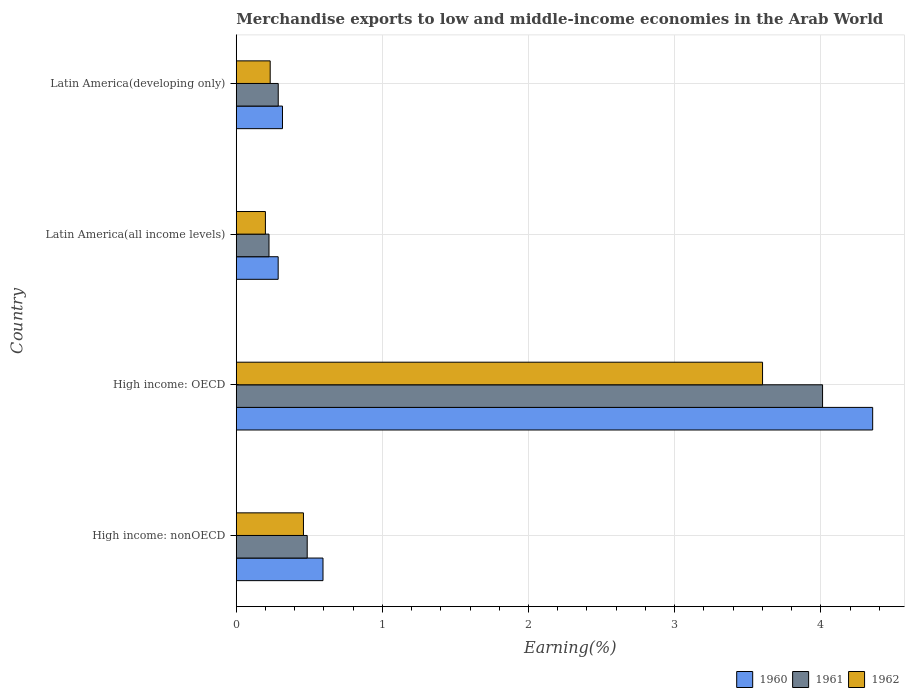How many groups of bars are there?
Keep it short and to the point. 4. Are the number of bars per tick equal to the number of legend labels?
Your response must be concise. Yes. Are the number of bars on each tick of the Y-axis equal?
Your answer should be very brief. Yes. How many bars are there on the 1st tick from the top?
Make the answer very short. 3. How many bars are there on the 2nd tick from the bottom?
Your answer should be compact. 3. What is the label of the 1st group of bars from the top?
Offer a terse response. Latin America(developing only). In how many cases, is the number of bars for a given country not equal to the number of legend labels?
Provide a short and direct response. 0. What is the percentage of amount earned from merchandise exports in 1962 in Latin America(developing only)?
Ensure brevity in your answer.  0.23. Across all countries, what is the maximum percentage of amount earned from merchandise exports in 1961?
Give a very brief answer. 4.01. Across all countries, what is the minimum percentage of amount earned from merchandise exports in 1960?
Keep it short and to the point. 0.29. In which country was the percentage of amount earned from merchandise exports in 1962 maximum?
Provide a succinct answer. High income: OECD. In which country was the percentage of amount earned from merchandise exports in 1960 minimum?
Offer a very short reply. Latin America(all income levels). What is the total percentage of amount earned from merchandise exports in 1960 in the graph?
Offer a terse response. 5.55. What is the difference between the percentage of amount earned from merchandise exports in 1960 in High income: nonOECD and that in Latin America(developing only)?
Your answer should be very brief. 0.28. What is the difference between the percentage of amount earned from merchandise exports in 1961 in Latin America(developing only) and the percentage of amount earned from merchandise exports in 1960 in High income: nonOECD?
Ensure brevity in your answer.  -0.31. What is the average percentage of amount earned from merchandise exports in 1961 per country?
Provide a succinct answer. 1.25. What is the difference between the percentage of amount earned from merchandise exports in 1961 and percentage of amount earned from merchandise exports in 1962 in High income: nonOECD?
Provide a short and direct response. 0.03. What is the ratio of the percentage of amount earned from merchandise exports in 1961 in High income: nonOECD to that in Latin America(all income levels)?
Provide a short and direct response. 2.17. Is the difference between the percentage of amount earned from merchandise exports in 1961 in High income: OECD and Latin America(all income levels) greater than the difference between the percentage of amount earned from merchandise exports in 1962 in High income: OECD and Latin America(all income levels)?
Offer a terse response. Yes. What is the difference between the highest and the second highest percentage of amount earned from merchandise exports in 1962?
Ensure brevity in your answer.  3.14. What is the difference between the highest and the lowest percentage of amount earned from merchandise exports in 1960?
Ensure brevity in your answer.  4.07. Is the sum of the percentage of amount earned from merchandise exports in 1961 in High income: OECD and High income: nonOECD greater than the maximum percentage of amount earned from merchandise exports in 1962 across all countries?
Your response must be concise. Yes. Is it the case that in every country, the sum of the percentage of amount earned from merchandise exports in 1960 and percentage of amount earned from merchandise exports in 1961 is greater than the percentage of amount earned from merchandise exports in 1962?
Make the answer very short. Yes. How many bars are there?
Offer a terse response. 12. How many countries are there in the graph?
Offer a terse response. 4. Does the graph contain grids?
Your answer should be compact. Yes. Where does the legend appear in the graph?
Make the answer very short. Bottom right. How many legend labels are there?
Your answer should be very brief. 3. How are the legend labels stacked?
Provide a short and direct response. Horizontal. What is the title of the graph?
Provide a short and direct response. Merchandise exports to low and middle-income economies in the Arab World. Does "1982" appear as one of the legend labels in the graph?
Provide a short and direct response. No. What is the label or title of the X-axis?
Give a very brief answer. Earning(%). What is the Earning(%) of 1960 in High income: nonOECD?
Provide a succinct answer. 0.59. What is the Earning(%) of 1961 in High income: nonOECD?
Provide a succinct answer. 0.49. What is the Earning(%) in 1962 in High income: nonOECD?
Give a very brief answer. 0.46. What is the Earning(%) of 1960 in High income: OECD?
Keep it short and to the point. 4.36. What is the Earning(%) in 1961 in High income: OECD?
Make the answer very short. 4.01. What is the Earning(%) of 1962 in High income: OECD?
Give a very brief answer. 3.6. What is the Earning(%) of 1960 in Latin America(all income levels)?
Your response must be concise. 0.29. What is the Earning(%) of 1961 in Latin America(all income levels)?
Provide a succinct answer. 0.22. What is the Earning(%) of 1962 in Latin America(all income levels)?
Make the answer very short. 0.2. What is the Earning(%) in 1960 in Latin America(developing only)?
Keep it short and to the point. 0.32. What is the Earning(%) of 1961 in Latin America(developing only)?
Your response must be concise. 0.29. What is the Earning(%) of 1962 in Latin America(developing only)?
Provide a short and direct response. 0.23. Across all countries, what is the maximum Earning(%) of 1960?
Give a very brief answer. 4.36. Across all countries, what is the maximum Earning(%) in 1961?
Offer a very short reply. 4.01. Across all countries, what is the maximum Earning(%) of 1962?
Your answer should be very brief. 3.6. Across all countries, what is the minimum Earning(%) in 1960?
Offer a very short reply. 0.29. Across all countries, what is the minimum Earning(%) of 1961?
Offer a very short reply. 0.22. Across all countries, what is the minimum Earning(%) of 1962?
Offer a very short reply. 0.2. What is the total Earning(%) of 1960 in the graph?
Give a very brief answer. 5.55. What is the total Earning(%) in 1961 in the graph?
Offer a terse response. 5.01. What is the total Earning(%) in 1962 in the graph?
Offer a very short reply. 4.49. What is the difference between the Earning(%) in 1960 in High income: nonOECD and that in High income: OECD?
Provide a succinct answer. -3.76. What is the difference between the Earning(%) in 1961 in High income: nonOECD and that in High income: OECD?
Ensure brevity in your answer.  -3.53. What is the difference between the Earning(%) in 1962 in High income: nonOECD and that in High income: OECD?
Your response must be concise. -3.14. What is the difference between the Earning(%) of 1960 in High income: nonOECD and that in Latin America(all income levels)?
Provide a short and direct response. 0.31. What is the difference between the Earning(%) in 1961 in High income: nonOECD and that in Latin America(all income levels)?
Offer a terse response. 0.26. What is the difference between the Earning(%) of 1962 in High income: nonOECD and that in Latin America(all income levels)?
Your answer should be compact. 0.26. What is the difference between the Earning(%) of 1960 in High income: nonOECD and that in Latin America(developing only)?
Provide a succinct answer. 0.28. What is the difference between the Earning(%) of 1961 in High income: nonOECD and that in Latin America(developing only)?
Your response must be concise. 0.2. What is the difference between the Earning(%) of 1962 in High income: nonOECD and that in Latin America(developing only)?
Your answer should be compact. 0.23. What is the difference between the Earning(%) in 1960 in High income: OECD and that in Latin America(all income levels)?
Make the answer very short. 4.07. What is the difference between the Earning(%) in 1961 in High income: OECD and that in Latin America(all income levels)?
Your answer should be compact. 3.79. What is the difference between the Earning(%) in 1962 in High income: OECD and that in Latin America(all income levels)?
Your answer should be very brief. 3.4. What is the difference between the Earning(%) of 1960 in High income: OECD and that in Latin America(developing only)?
Provide a succinct answer. 4.04. What is the difference between the Earning(%) in 1961 in High income: OECD and that in Latin America(developing only)?
Your answer should be very brief. 3.72. What is the difference between the Earning(%) of 1962 in High income: OECD and that in Latin America(developing only)?
Offer a very short reply. 3.37. What is the difference between the Earning(%) of 1960 in Latin America(all income levels) and that in Latin America(developing only)?
Your response must be concise. -0.03. What is the difference between the Earning(%) of 1961 in Latin America(all income levels) and that in Latin America(developing only)?
Offer a very short reply. -0.06. What is the difference between the Earning(%) of 1962 in Latin America(all income levels) and that in Latin America(developing only)?
Provide a succinct answer. -0.03. What is the difference between the Earning(%) in 1960 in High income: nonOECD and the Earning(%) in 1961 in High income: OECD?
Keep it short and to the point. -3.42. What is the difference between the Earning(%) in 1960 in High income: nonOECD and the Earning(%) in 1962 in High income: OECD?
Ensure brevity in your answer.  -3.01. What is the difference between the Earning(%) of 1961 in High income: nonOECD and the Earning(%) of 1962 in High income: OECD?
Give a very brief answer. -3.12. What is the difference between the Earning(%) in 1960 in High income: nonOECD and the Earning(%) in 1961 in Latin America(all income levels)?
Ensure brevity in your answer.  0.37. What is the difference between the Earning(%) of 1960 in High income: nonOECD and the Earning(%) of 1962 in Latin America(all income levels)?
Provide a succinct answer. 0.39. What is the difference between the Earning(%) of 1961 in High income: nonOECD and the Earning(%) of 1962 in Latin America(all income levels)?
Keep it short and to the point. 0.29. What is the difference between the Earning(%) of 1960 in High income: nonOECD and the Earning(%) of 1961 in Latin America(developing only)?
Give a very brief answer. 0.31. What is the difference between the Earning(%) in 1960 in High income: nonOECD and the Earning(%) in 1962 in Latin America(developing only)?
Your response must be concise. 0.36. What is the difference between the Earning(%) of 1961 in High income: nonOECD and the Earning(%) of 1962 in Latin America(developing only)?
Ensure brevity in your answer.  0.25. What is the difference between the Earning(%) of 1960 in High income: OECD and the Earning(%) of 1961 in Latin America(all income levels)?
Offer a terse response. 4.13. What is the difference between the Earning(%) in 1960 in High income: OECD and the Earning(%) in 1962 in Latin America(all income levels)?
Your response must be concise. 4.16. What is the difference between the Earning(%) of 1961 in High income: OECD and the Earning(%) of 1962 in Latin America(all income levels)?
Your answer should be very brief. 3.81. What is the difference between the Earning(%) of 1960 in High income: OECD and the Earning(%) of 1961 in Latin America(developing only)?
Provide a succinct answer. 4.07. What is the difference between the Earning(%) of 1960 in High income: OECD and the Earning(%) of 1962 in Latin America(developing only)?
Your answer should be very brief. 4.12. What is the difference between the Earning(%) of 1961 in High income: OECD and the Earning(%) of 1962 in Latin America(developing only)?
Provide a succinct answer. 3.78. What is the difference between the Earning(%) in 1960 in Latin America(all income levels) and the Earning(%) in 1961 in Latin America(developing only)?
Ensure brevity in your answer.  -0. What is the difference between the Earning(%) of 1960 in Latin America(all income levels) and the Earning(%) of 1962 in Latin America(developing only)?
Your answer should be compact. 0.05. What is the difference between the Earning(%) of 1961 in Latin America(all income levels) and the Earning(%) of 1962 in Latin America(developing only)?
Provide a succinct answer. -0.01. What is the average Earning(%) of 1960 per country?
Provide a succinct answer. 1.39. What is the average Earning(%) in 1961 per country?
Provide a succinct answer. 1.25. What is the average Earning(%) in 1962 per country?
Offer a very short reply. 1.12. What is the difference between the Earning(%) of 1960 and Earning(%) of 1961 in High income: nonOECD?
Offer a very short reply. 0.11. What is the difference between the Earning(%) of 1960 and Earning(%) of 1962 in High income: nonOECD?
Your answer should be very brief. 0.13. What is the difference between the Earning(%) in 1961 and Earning(%) in 1962 in High income: nonOECD?
Offer a very short reply. 0.03. What is the difference between the Earning(%) in 1960 and Earning(%) in 1961 in High income: OECD?
Keep it short and to the point. 0.34. What is the difference between the Earning(%) in 1960 and Earning(%) in 1962 in High income: OECD?
Keep it short and to the point. 0.75. What is the difference between the Earning(%) of 1961 and Earning(%) of 1962 in High income: OECD?
Provide a short and direct response. 0.41. What is the difference between the Earning(%) of 1960 and Earning(%) of 1961 in Latin America(all income levels)?
Offer a very short reply. 0.06. What is the difference between the Earning(%) in 1960 and Earning(%) in 1962 in Latin America(all income levels)?
Make the answer very short. 0.09. What is the difference between the Earning(%) in 1961 and Earning(%) in 1962 in Latin America(all income levels)?
Your answer should be compact. 0.02. What is the difference between the Earning(%) in 1960 and Earning(%) in 1961 in Latin America(developing only)?
Your answer should be compact. 0.03. What is the difference between the Earning(%) of 1960 and Earning(%) of 1962 in Latin America(developing only)?
Provide a succinct answer. 0.08. What is the difference between the Earning(%) of 1961 and Earning(%) of 1962 in Latin America(developing only)?
Your answer should be compact. 0.06. What is the ratio of the Earning(%) in 1960 in High income: nonOECD to that in High income: OECD?
Your response must be concise. 0.14. What is the ratio of the Earning(%) of 1961 in High income: nonOECD to that in High income: OECD?
Make the answer very short. 0.12. What is the ratio of the Earning(%) in 1962 in High income: nonOECD to that in High income: OECD?
Your response must be concise. 0.13. What is the ratio of the Earning(%) of 1960 in High income: nonOECD to that in Latin America(all income levels)?
Ensure brevity in your answer.  2.07. What is the ratio of the Earning(%) of 1961 in High income: nonOECD to that in Latin America(all income levels)?
Provide a short and direct response. 2.17. What is the ratio of the Earning(%) in 1962 in High income: nonOECD to that in Latin America(all income levels)?
Give a very brief answer. 2.31. What is the ratio of the Earning(%) of 1960 in High income: nonOECD to that in Latin America(developing only)?
Ensure brevity in your answer.  1.88. What is the ratio of the Earning(%) of 1961 in High income: nonOECD to that in Latin America(developing only)?
Provide a succinct answer. 1.69. What is the ratio of the Earning(%) in 1962 in High income: nonOECD to that in Latin America(developing only)?
Make the answer very short. 1.98. What is the ratio of the Earning(%) in 1960 in High income: OECD to that in Latin America(all income levels)?
Offer a terse response. 15.18. What is the ratio of the Earning(%) in 1961 in High income: OECD to that in Latin America(all income levels)?
Ensure brevity in your answer.  17.9. What is the ratio of the Earning(%) in 1962 in High income: OECD to that in Latin America(all income levels)?
Keep it short and to the point. 18.05. What is the ratio of the Earning(%) in 1960 in High income: OECD to that in Latin America(developing only)?
Make the answer very short. 13.77. What is the ratio of the Earning(%) of 1961 in High income: OECD to that in Latin America(developing only)?
Provide a short and direct response. 13.96. What is the ratio of the Earning(%) of 1962 in High income: OECD to that in Latin America(developing only)?
Ensure brevity in your answer.  15.51. What is the ratio of the Earning(%) of 1960 in Latin America(all income levels) to that in Latin America(developing only)?
Keep it short and to the point. 0.91. What is the ratio of the Earning(%) of 1961 in Latin America(all income levels) to that in Latin America(developing only)?
Ensure brevity in your answer.  0.78. What is the ratio of the Earning(%) of 1962 in Latin America(all income levels) to that in Latin America(developing only)?
Provide a succinct answer. 0.86. What is the difference between the highest and the second highest Earning(%) in 1960?
Provide a succinct answer. 3.76. What is the difference between the highest and the second highest Earning(%) of 1961?
Make the answer very short. 3.53. What is the difference between the highest and the second highest Earning(%) in 1962?
Keep it short and to the point. 3.14. What is the difference between the highest and the lowest Earning(%) of 1960?
Provide a short and direct response. 4.07. What is the difference between the highest and the lowest Earning(%) of 1961?
Ensure brevity in your answer.  3.79. What is the difference between the highest and the lowest Earning(%) in 1962?
Offer a terse response. 3.4. 